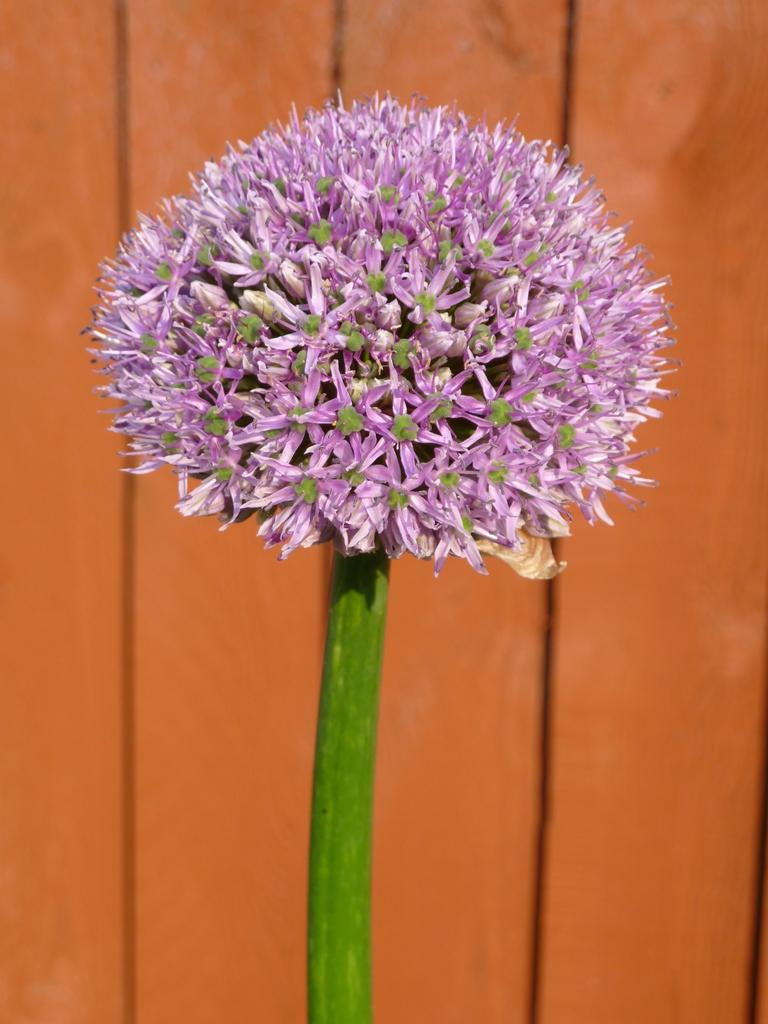What is the main subject of the image? There is a flower in the center of the image. What color is the flower? The flower is pink in color. What can be seen in the background of the image? There is a wooden wall in the background of the image. How does the flower express its anger in the image? The flower does not express anger in the image, as it is an inanimate object and does not have emotions. 